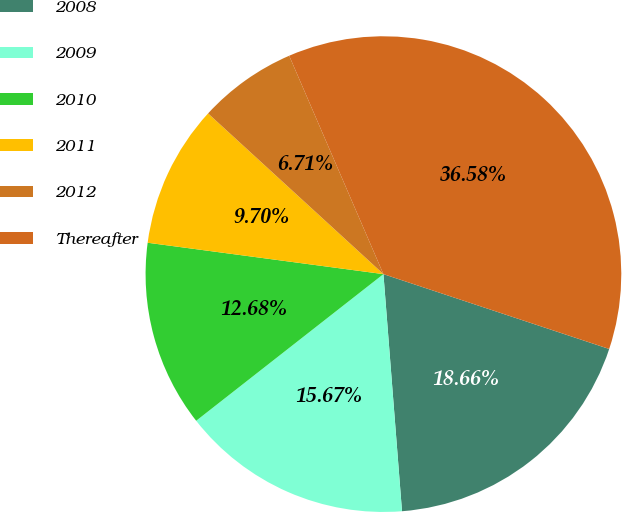Convert chart. <chart><loc_0><loc_0><loc_500><loc_500><pie_chart><fcel>2008<fcel>2009<fcel>2010<fcel>2011<fcel>2012<fcel>Thereafter<nl><fcel>18.66%<fcel>15.67%<fcel>12.68%<fcel>9.7%<fcel>6.71%<fcel>36.58%<nl></chart> 